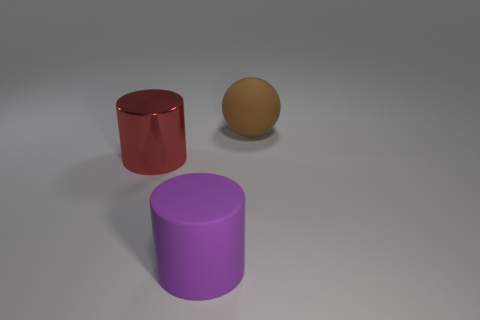Add 1 brown things. How many objects exist? 4 Subtract all spheres. How many objects are left? 2 Add 2 big red objects. How many big red objects are left? 3 Add 1 big brown objects. How many big brown objects exist? 2 Subtract 1 purple cylinders. How many objects are left? 2 Subtract all large brown objects. Subtract all brown matte things. How many objects are left? 1 